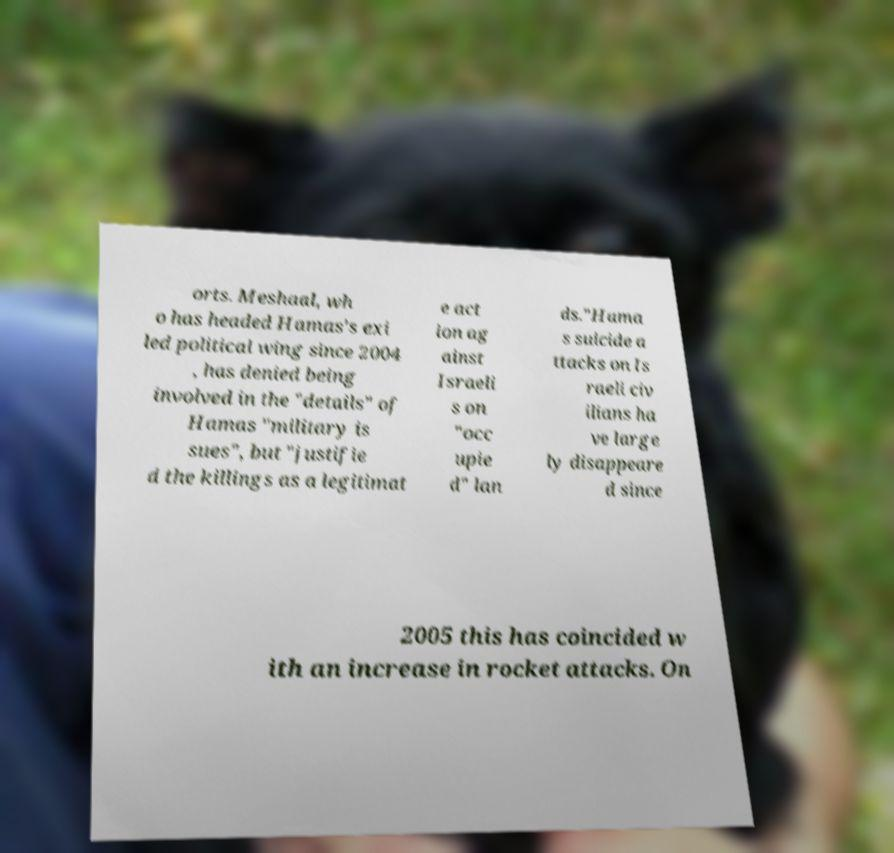Could you extract and type out the text from this image? orts. Meshaal, wh o has headed Hamas's exi led political wing since 2004 , has denied being involved in the "details" of Hamas "military is sues", but "justifie d the killings as a legitimat e act ion ag ainst Israeli s on "occ upie d" lan ds."Hama s suicide a ttacks on Is raeli civ ilians ha ve large ly disappeare d since 2005 this has coincided w ith an increase in rocket attacks. On 